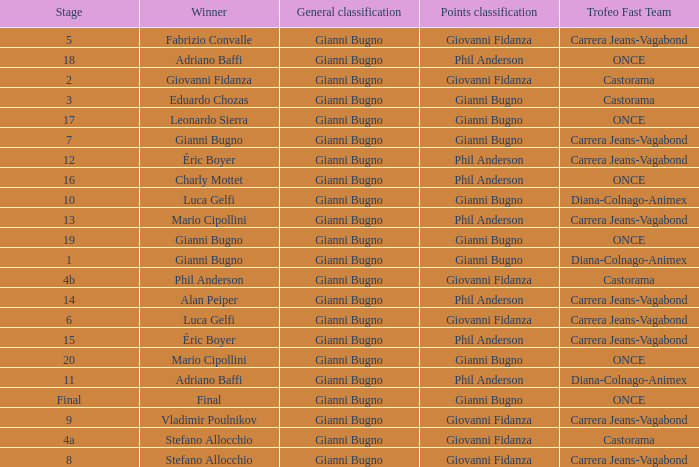Would you mind parsing the complete table? {'header': ['Stage', 'Winner', 'General classification', 'Points classification', 'Trofeo Fast Team'], 'rows': [['5', 'Fabrizio Convalle', 'Gianni Bugno', 'Giovanni Fidanza', 'Carrera Jeans-Vagabond'], ['18', 'Adriano Baffi', 'Gianni Bugno', 'Phil Anderson', 'ONCE'], ['2', 'Giovanni Fidanza', 'Gianni Bugno', 'Giovanni Fidanza', 'Castorama'], ['3', 'Eduardo Chozas', 'Gianni Bugno', 'Gianni Bugno', 'Castorama'], ['17', 'Leonardo Sierra', 'Gianni Bugno', 'Gianni Bugno', 'ONCE'], ['7', 'Gianni Bugno', 'Gianni Bugno', 'Gianni Bugno', 'Carrera Jeans-Vagabond'], ['12', 'Éric Boyer', 'Gianni Bugno', 'Phil Anderson', 'Carrera Jeans-Vagabond'], ['16', 'Charly Mottet', 'Gianni Bugno', 'Phil Anderson', 'ONCE'], ['10', 'Luca Gelfi', 'Gianni Bugno', 'Gianni Bugno', 'Diana-Colnago-Animex'], ['13', 'Mario Cipollini', 'Gianni Bugno', 'Phil Anderson', 'Carrera Jeans-Vagabond'], ['19', 'Gianni Bugno', 'Gianni Bugno', 'Gianni Bugno', 'ONCE'], ['1', 'Gianni Bugno', 'Gianni Bugno', 'Gianni Bugno', 'Diana-Colnago-Animex'], ['4b', 'Phil Anderson', 'Gianni Bugno', 'Giovanni Fidanza', 'Castorama'], ['14', 'Alan Peiper', 'Gianni Bugno', 'Phil Anderson', 'Carrera Jeans-Vagabond'], ['6', 'Luca Gelfi', 'Gianni Bugno', 'Giovanni Fidanza', 'Carrera Jeans-Vagabond'], ['15', 'Éric Boyer', 'Gianni Bugno', 'Phil Anderson', 'Carrera Jeans-Vagabond'], ['20', 'Mario Cipollini', 'Gianni Bugno', 'Gianni Bugno', 'ONCE'], ['11', 'Adriano Baffi', 'Gianni Bugno', 'Phil Anderson', 'Diana-Colnago-Animex'], ['Final', 'Final', 'Gianni Bugno', 'Gianni Bugno', 'ONCE'], ['9', 'Vladimir Poulnikov', 'Gianni Bugno', 'Giovanni Fidanza', 'Carrera Jeans-Vagabond'], ['4a', 'Stefano Allocchio', 'Gianni Bugno', 'Giovanni Fidanza', 'Castorama'], ['8', 'Stefano Allocchio', 'Gianni Bugno', 'Giovanni Fidanza', 'Carrera Jeans-Vagabond']]} Who is the trofeo fast team in stage 10? Diana-Colnago-Animex. 